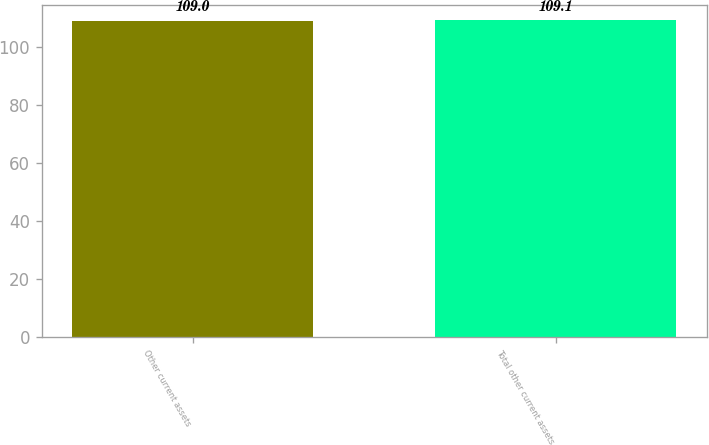Convert chart to OTSL. <chart><loc_0><loc_0><loc_500><loc_500><bar_chart><fcel>Other current assets<fcel>Total other current assets<nl><fcel>109<fcel>109.1<nl></chart> 